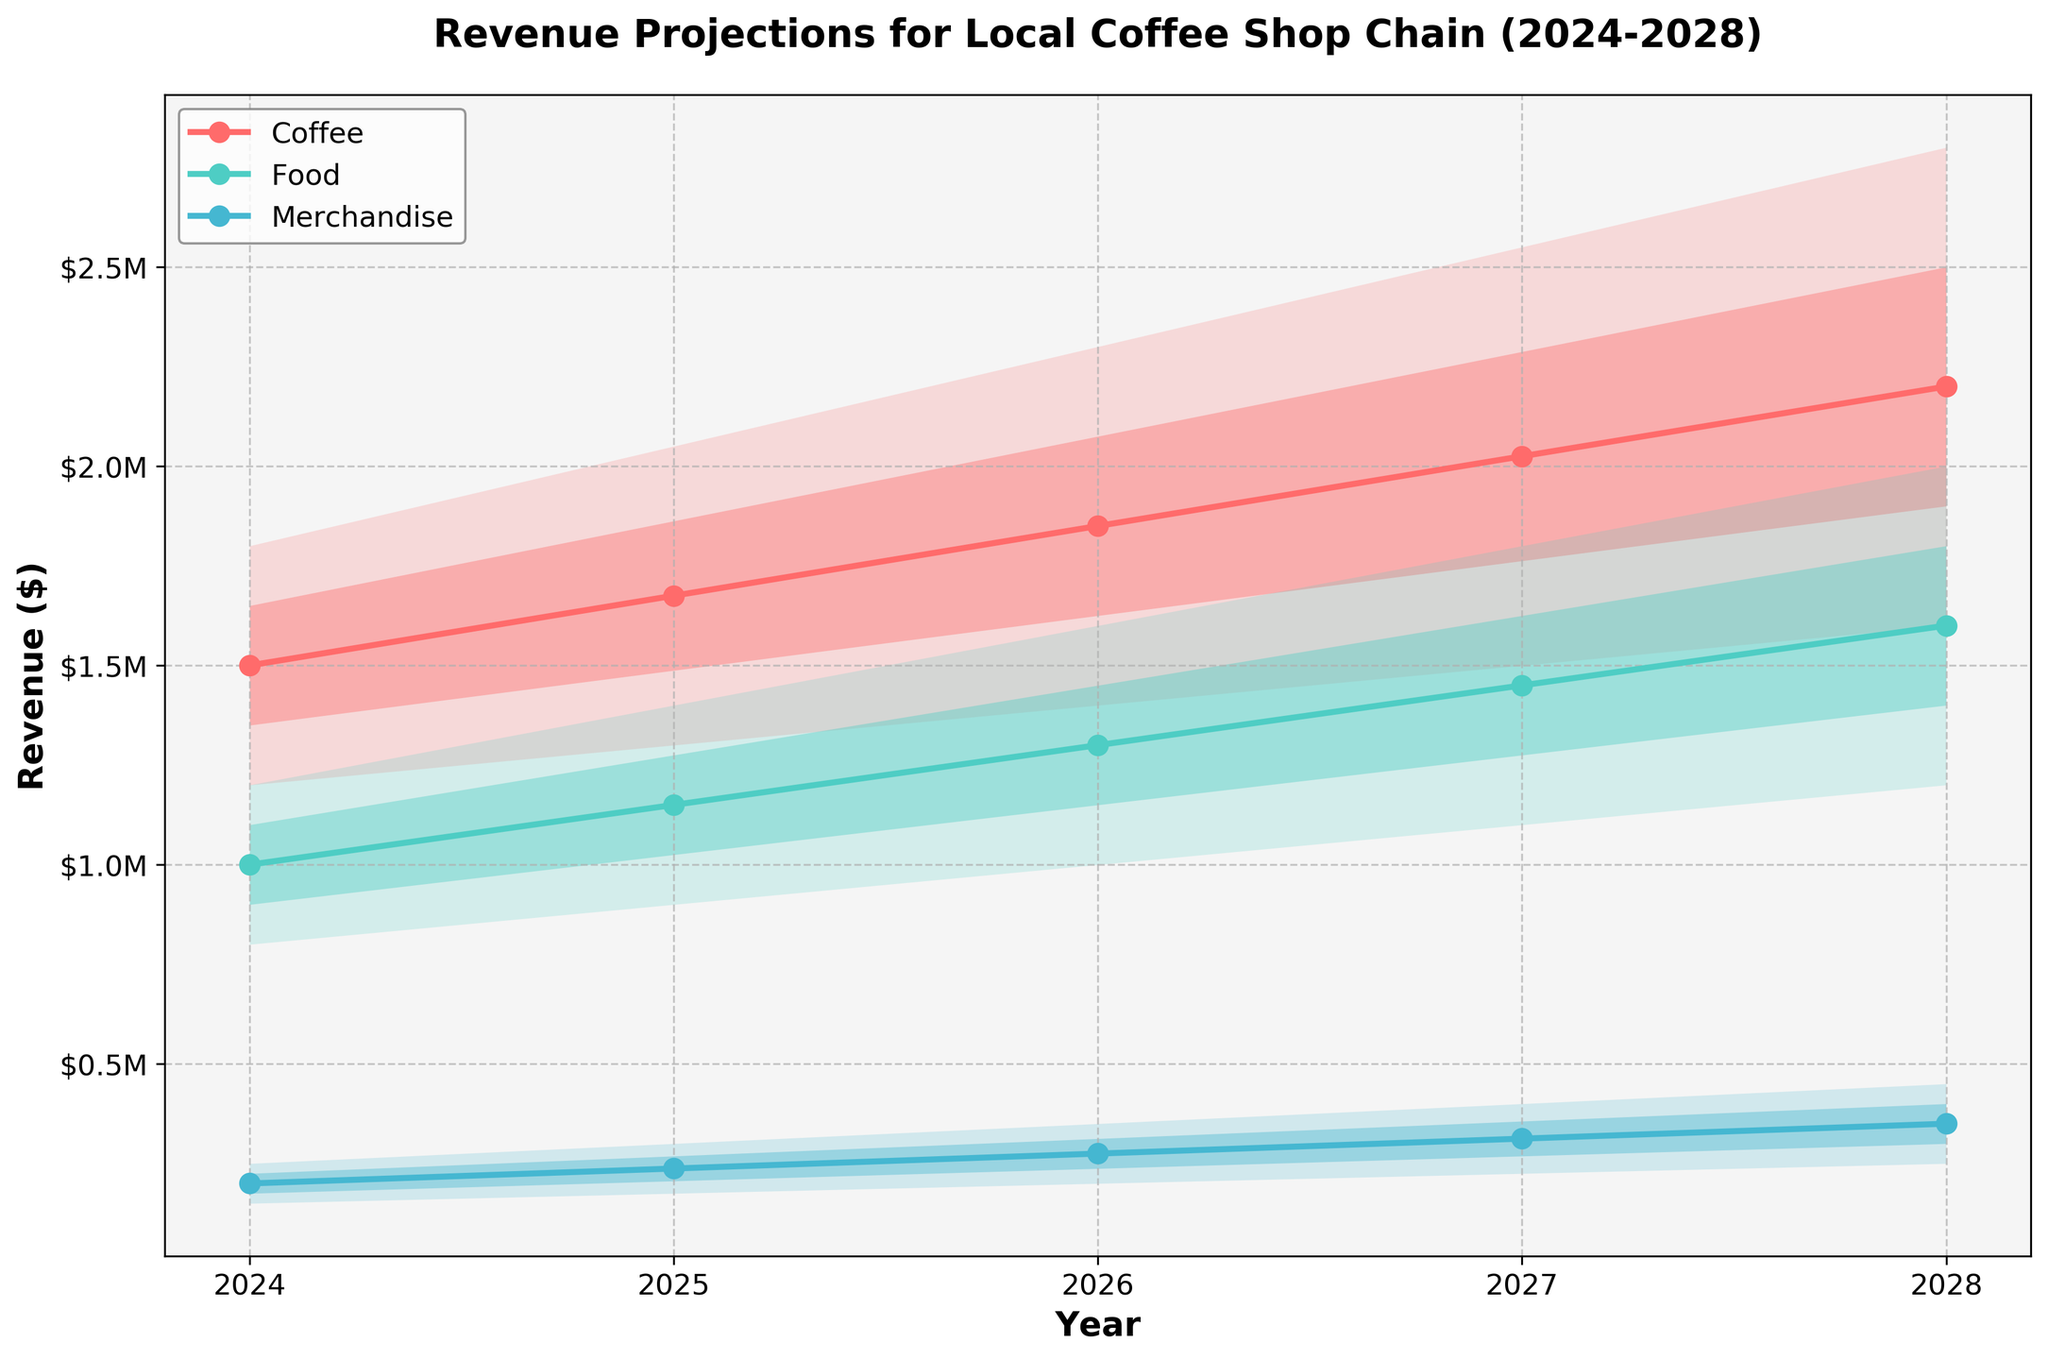Which year has the highest mid-estimate revenue for coffee? Locate the mid-estimate line for coffee and observe the year with the peak value. The coffee line is shown in blue on the chart. The value is highest in 2028.
Answer: 2028 What is the expected revenue range for food in 2025? Look at the upper and lower bounds for food in 2025. The values are given from 900,000 to 1,400,000.
Answer: $900,000 - $1,400,000 How many product categories are projected in the chart? Check the legend or the different colored lines to count the number of categories displayed. There are three lines, each representing a category (coffee, food, merchandise).
Answer: 3 How does the highest high-estimate revenue for merchandise in 2024 compare to the mid-estimate revenue for coffee in 2024? Locate the highest high-estimate for merchandise in 2024 (250,000) and mid-estimate for coffee in 2024 (1,500,000). Then compare these values to find the difference.
Answer: The mid-estimate revenue for coffee is $1,250,000 higher Which product category shows the highest growth in mid-estimate revenue from 2024 to 2028? Calculate the difference between the mid-estimate revenues from 2024 to 2028 for each category. Coffee: 2,200,000 - 1,500,000 = 700,000; Food: 1,600,000 - 1,000,000 = 600,000; Merchandise: 350,000 - 200,000 = 150,000.
Answer: Coffee Which year shows the smallest revenue projection range for merchandise? Find the year with the smallest difference between the high estimate and low estimate for the merchandise category. Calculate the ranges: 2024: 250,000 - 150,000 = 100,000; 2025: 300,000 - 175,000 = 125,000; 2026: 350,000 - 200,000 = 150,000; 2027: 400,000 - 225,000 = 175,000; 2028: 450,000 - 250,000 = 200,000. The smallest range is in 2024.
Answer: 2024 